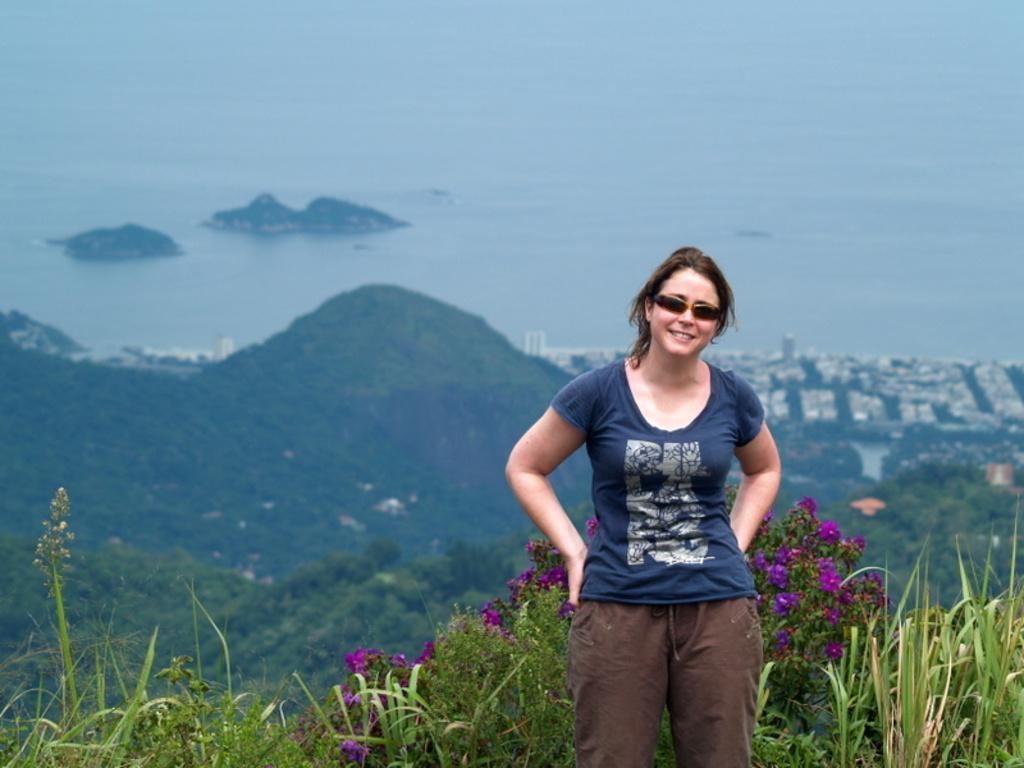Please provide a concise description of this image. In the foreground of the picture I can see a woman wearing a T-shirt and there is a smile on her face. I can see the flowering plants and green grass at the bottom of the picture. In the background, I can see the buildings, ocean and hill. 